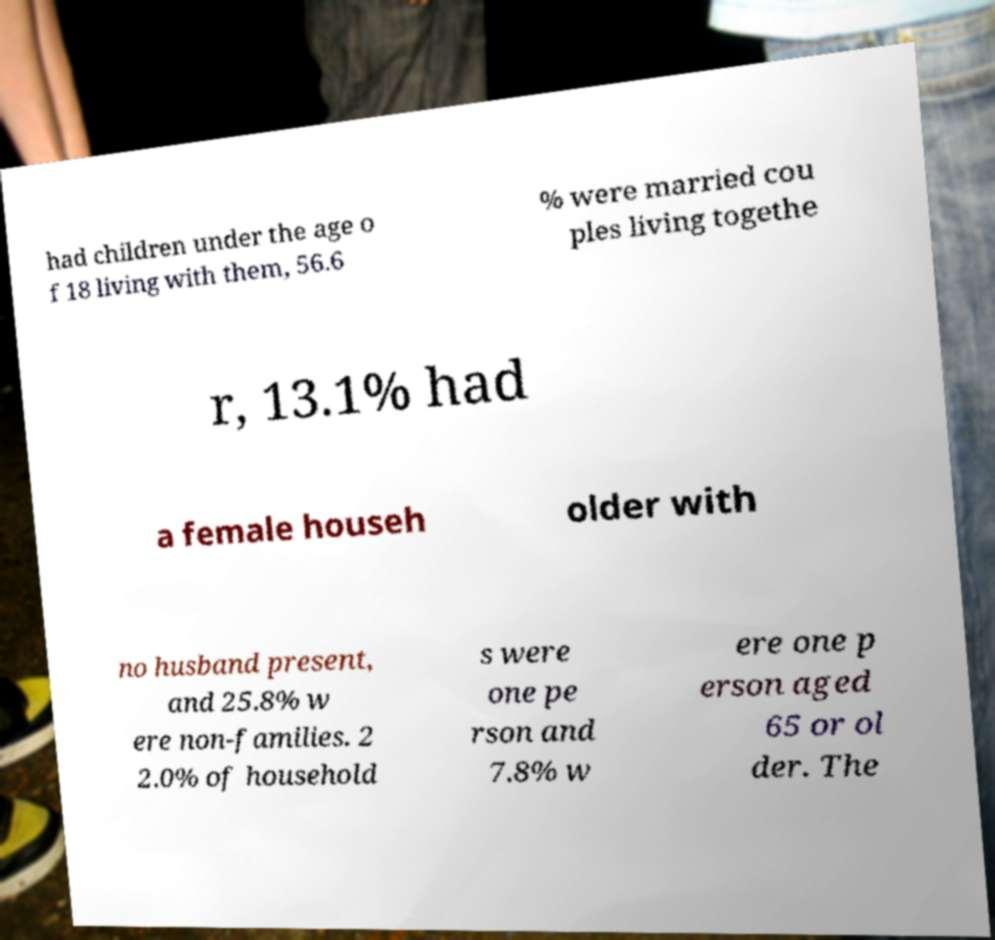Could you assist in decoding the text presented in this image and type it out clearly? had children under the age o f 18 living with them, 56.6 % were married cou ples living togethe r, 13.1% had a female househ older with no husband present, and 25.8% w ere non-families. 2 2.0% of household s were one pe rson and 7.8% w ere one p erson aged 65 or ol der. The 